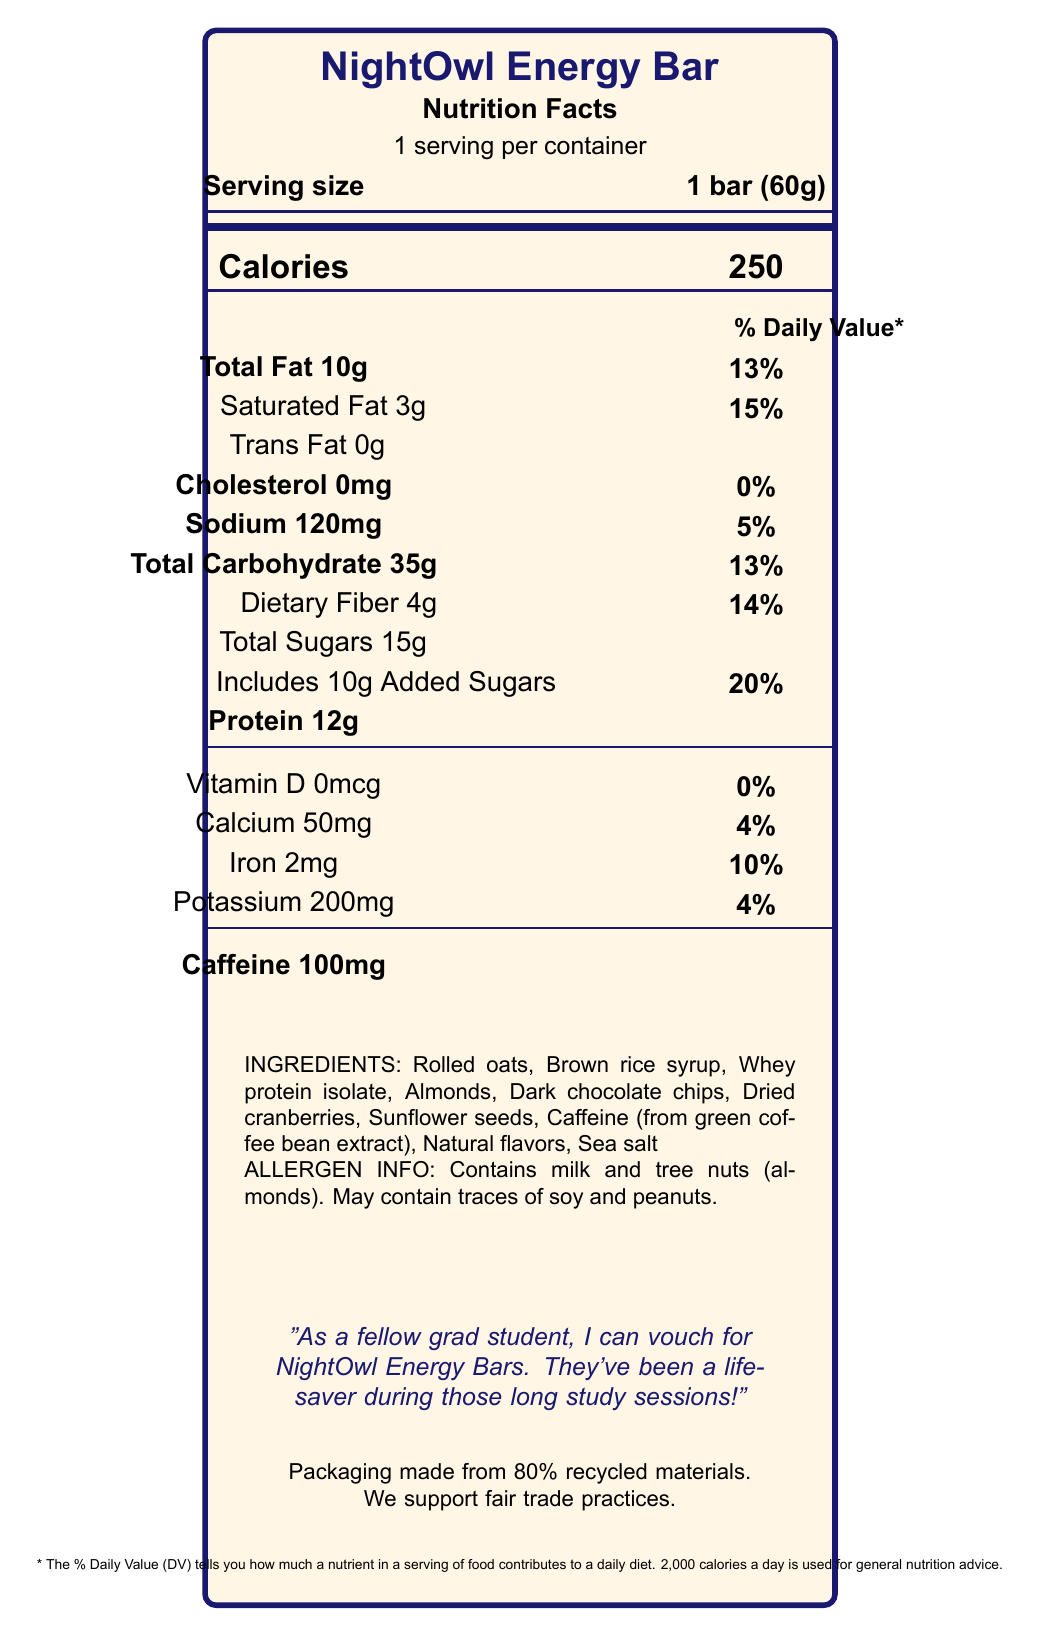what is the serving size of NightOwl Energy Bar? The document clearly states the serving size as '1 bar (60g)' near the top.
Answer: 1 bar (60g) how many calories does one NightOwl Energy Bar contain? The document lists 'Calories 250' in a prominent position.
Answer: 250 what percentage of the daily value of saturated fat is in one serving of the bar? Under the 'Total Fat' section, the document lists saturated fat as 3g, which is 15% of the daily value.
Answer: 15% what is the amount of added sugars in one serving? The document mentions 'Includes 10g Added Sugars' along with the percentage daily value of 20%.
Answer: 10g what are the allergens present in NightOwl Energy Bar? The allergen information section clearly states the presence of milk and tree nuts (almonds).
Answer: Milk and tree nuts (almonds). how much protein is in one serving of the bar? The nutritional information section lists 'Protein 12g'.
Answer: 12g what special features does the NightOwl Energy Bar offer? The document lists these under 'Special Features'.
Answer: Slow-release carbohydrates, Added B-vitamins, No artificial preservatives or colors, Gluten-free how much iron does one serving provide? A. 2mg B. 2mcg C. 5mg D. 5mcg The nutritional information shows iron content as 'Iron 2mg'.
Answer: A. 2mg what is the amount of caffeine included in one NightOwl Energy Bar? A. 50mg B. 100mg C. 150mg D. 200mg The document states 'Caffeine 100mg' in the nutrition section.
Answer: B. 100mg is there any trans fat in NightOwl Energy Bar? The document lists 'Trans Fat 0g', indicating there is no trans fat in the energy bar.
Answer: No does NightOwl Energy Bar contain artificial preservatives? The list of special features mentions 'No artificial preservatives or colors'.
Answer: No summarize the main idea of the document. The document details the nutritional facts, ingredients, special features, allergen information, and the brand story of the NightOwl Energy Bar, emphasizing its suitability for students and its environmentally conscious packaging.
Answer: The NightOwl Energy Bar is designed for late-night study sessions, providing 250 calories, 12g of protein, 100mg of caffeine, and various nutrients with no artificial preservatives. It supports students with sustained energy and is made with eco-friendly packaging. how does the bar support sustained energy for late-night studies? The document mentions 'Slow-release carbohydrates for sustained energy' and lists 100mg of caffeine as part of the nutritional information.
Answer: Through slow-release carbohydrates and 100mg of caffeine what is the sodium content in one serving of NightOwl Energy Bar? The document lists 'Sodium 120mg' along with the daily value percentage of 5%.
Answer: 120mg what is the flavoring source of caffeine in the bar? The ingredients list mentions 'Caffeine (from green coffee bean extract)'.
Answer: Green coffee bean extract how many calories come from fats in the NightOwl Energy Bar? The document does not provide information on how many calories specifically come from fats.
Answer: Cannot be determined 